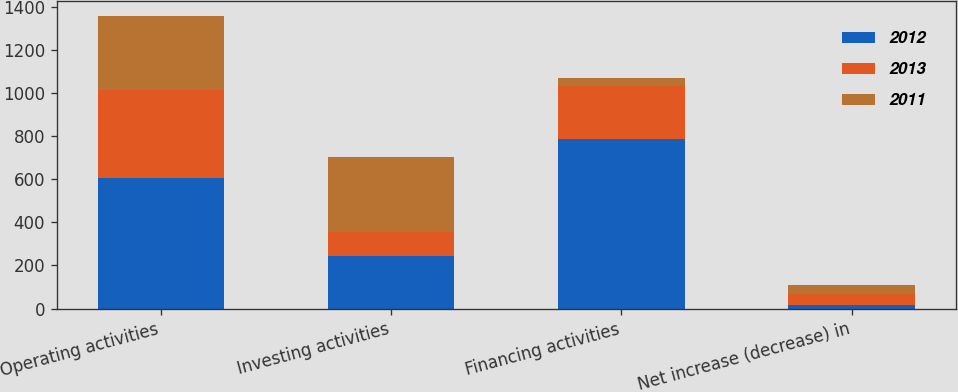Convert chart. <chart><loc_0><loc_0><loc_500><loc_500><stacked_bar_chart><ecel><fcel>Operating activities<fcel>Investing activities<fcel>Financing activities<fcel>Net increase (decrease) in<nl><fcel>2012<fcel>608.2<fcel>245.6<fcel>786.8<fcel>16.4<nl><fcel>2013<fcel>404.2<fcel>107.5<fcel>245.6<fcel>51.1<nl><fcel>2011<fcel>345.5<fcel>350.1<fcel>35.6<fcel>40.2<nl></chart> 